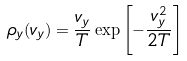Convert formula to latex. <formula><loc_0><loc_0><loc_500><loc_500>\rho _ { y } ( v _ { y } ) = \frac { v _ { y } } { T } \exp \left [ - \frac { v _ { y } ^ { 2 } } { 2 T } \right ]</formula> 